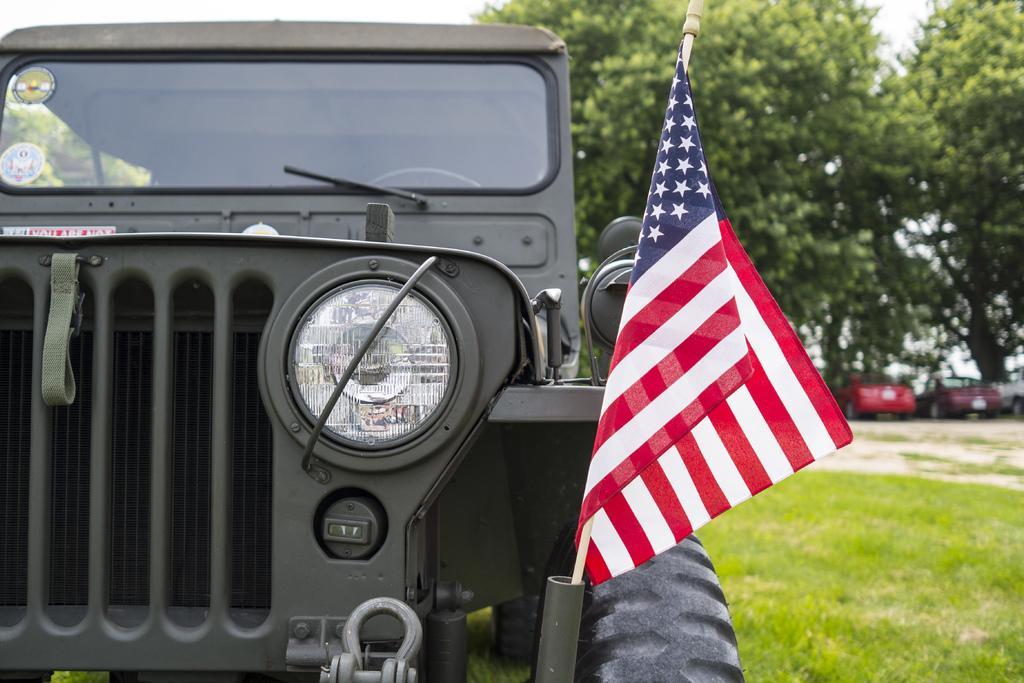In one or two sentences, can you explain what this image depicts? In this image, we can see a vehicle with flag on the grass. Here we can see two stickers on the glass. Background there is a blur view. Here we can see trees and vehicles. 